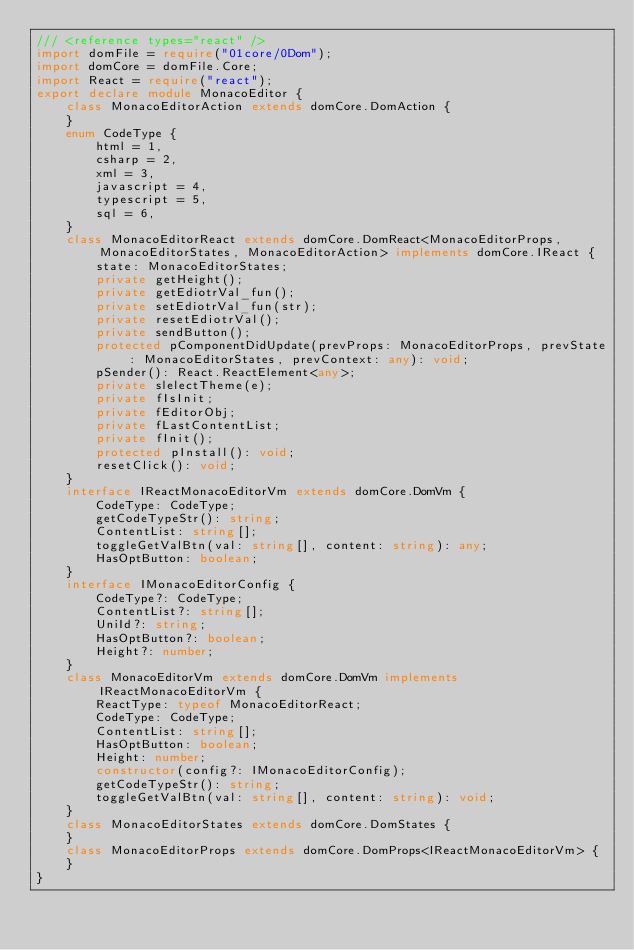Convert code to text. <code><loc_0><loc_0><loc_500><loc_500><_TypeScript_>/// <reference types="react" />
import domFile = require("01core/0Dom");
import domCore = domFile.Core;
import React = require("react");
export declare module MonacoEditor {
    class MonacoEditorAction extends domCore.DomAction {
    }
    enum CodeType {
        html = 1,
        csharp = 2,
        xml = 3,
        javascript = 4,
        typescript = 5,
        sql = 6,
    }
    class MonacoEditorReact extends domCore.DomReact<MonacoEditorProps, MonacoEditorStates, MonacoEditorAction> implements domCore.IReact {
        state: MonacoEditorStates;
        private getHeight();
        private getEdiotrVal_fun();
        private setEdiotrVal_fun(str);
        private resetEdiotrVal();
        private sendButton();
        protected pComponentDidUpdate(prevProps: MonacoEditorProps, prevState: MonacoEditorStates, prevContext: any): void;
        pSender(): React.ReactElement<any>;
        private slelectTheme(e);
        private fIsInit;
        private fEditorObj;
        private fLastContentList;
        private fInit();
        protected pInstall(): void;
        resetClick(): void;
    }
    interface IReactMonacoEditorVm extends domCore.DomVm {
        CodeType: CodeType;
        getCodeTypeStr(): string;
        ContentList: string[];
        toggleGetValBtn(val: string[], content: string): any;
        HasOptButton: boolean;
    }
    interface IMonacoEditorConfig {
        CodeType?: CodeType;
        ContentList?: string[];
        UniId?: string;
        HasOptButton?: boolean;
        Height?: number;
    }
    class MonacoEditorVm extends domCore.DomVm implements IReactMonacoEditorVm {
        ReactType: typeof MonacoEditorReact;
        CodeType: CodeType;
        ContentList: string[];
        HasOptButton: boolean;
        Height: number;
        constructor(config?: IMonacoEditorConfig);
        getCodeTypeStr(): string;
        toggleGetValBtn(val: string[], content: string): void;
    }
    class MonacoEditorStates extends domCore.DomStates {
    }
    class MonacoEditorProps extends domCore.DomProps<IReactMonacoEditorVm> {
    }
}
</code> 